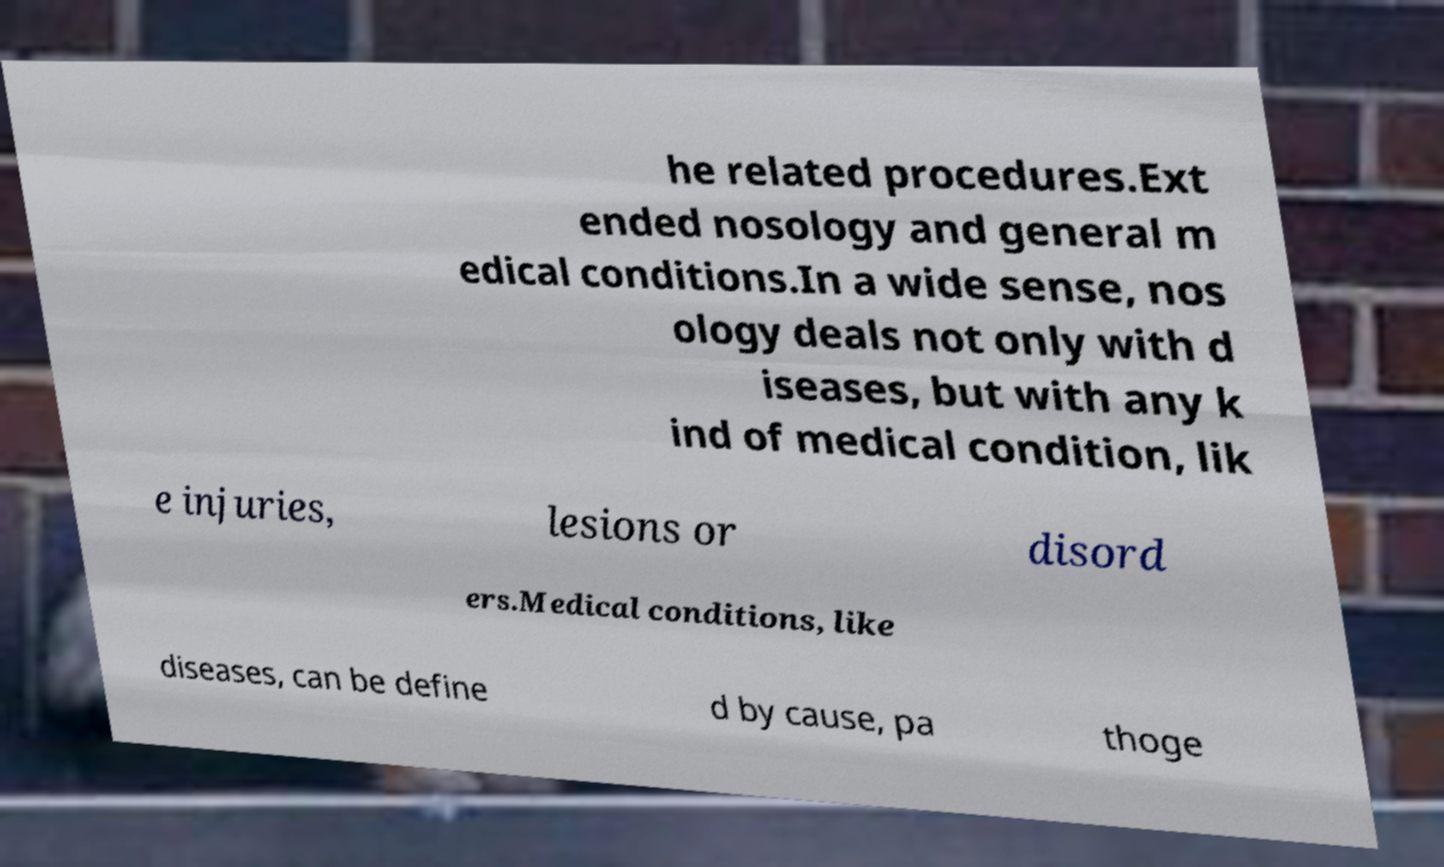Could you assist in decoding the text presented in this image and type it out clearly? he related procedures.Ext ended nosology and general m edical conditions.In a wide sense, nos ology deals not only with d iseases, but with any k ind of medical condition, lik e injuries, lesions or disord ers.Medical conditions, like diseases, can be define d by cause, pa thoge 